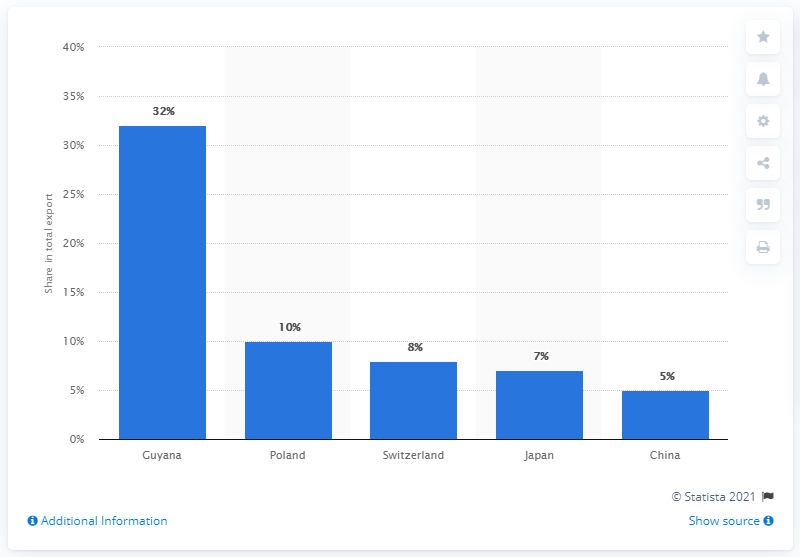Identify some key points in this picture. The sum total of exports in Poland and Switzerland in 2019 was not greater than Guyana. The value of exports in China is approximately 5.. In 2019, Guyana was the most important export partner of Liberia. 